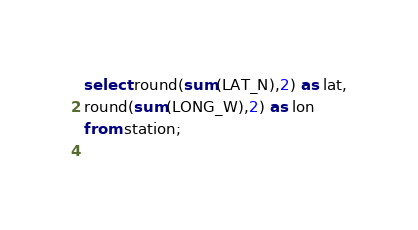<code> <loc_0><loc_0><loc_500><loc_500><_SQL_>select round(sum(LAT_N),2) as lat,
round(sum(LONG_W),2) as lon
from station;
             
</code> 